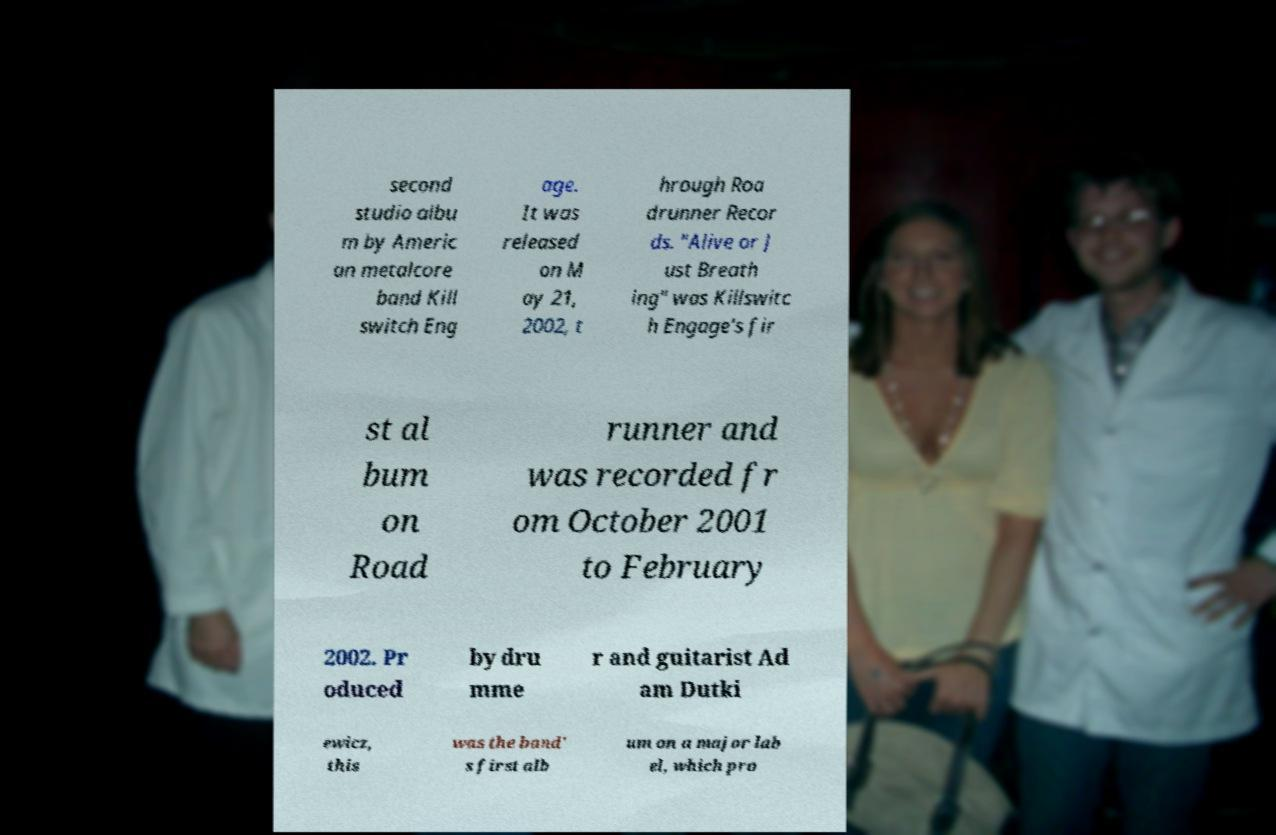For documentation purposes, I need the text within this image transcribed. Could you provide that? second studio albu m by Americ an metalcore band Kill switch Eng age. It was released on M ay 21, 2002, t hrough Roa drunner Recor ds. "Alive or J ust Breath ing" was Killswitc h Engage's fir st al bum on Road runner and was recorded fr om October 2001 to February 2002. Pr oduced by dru mme r and guitarist Ad am Dutki ewicz, this was the band' s first alb um on a major lab el, which pro 